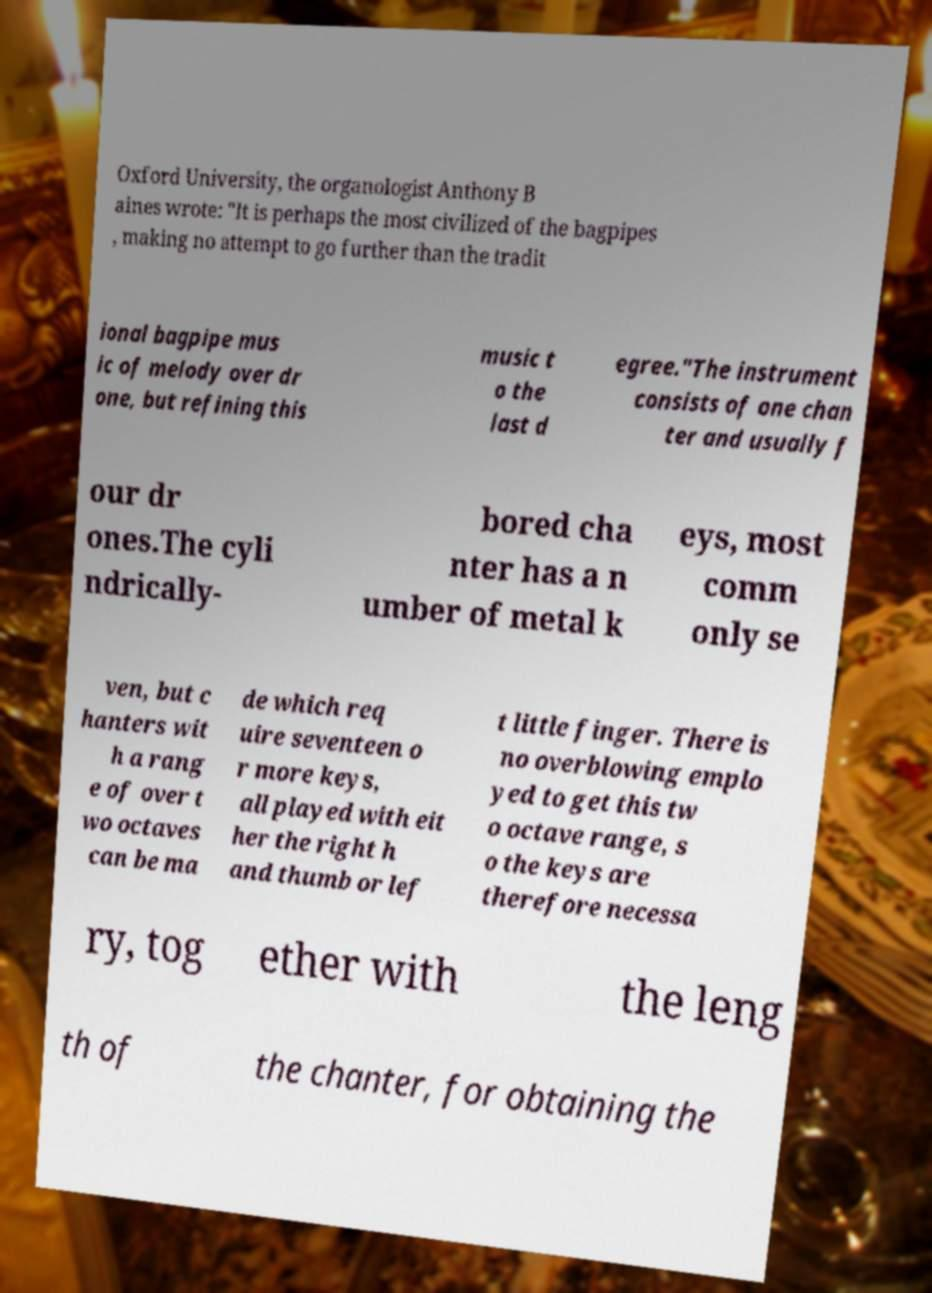What messages or text are displayed in this image? I need them in a readable, typed format. Oxford University, the organologist Anthony B aines wrote: "It is perhaps the most civilized of the bagpipes , making no attempt to go further than the tradit ional bagpipe mus ic of melody over dr one, but refining this music t o the last d egree."The instrument consists of one chan ter and usually f our dr ones.The cyli ndrically- bored cha nter has a n umber of metal k eys, most comm only se ven, but c hanters wit h a rang e of over t wo octaves can be ma de which req uire seventeen o r more keys, all played with eit her the right h and thumb or lef t little finger. There is no overblowing emplo yed to get this tw o octave range, s o the keys are therefore necessa ry, tog ether with the leng th of the chanter, for obtaining the 